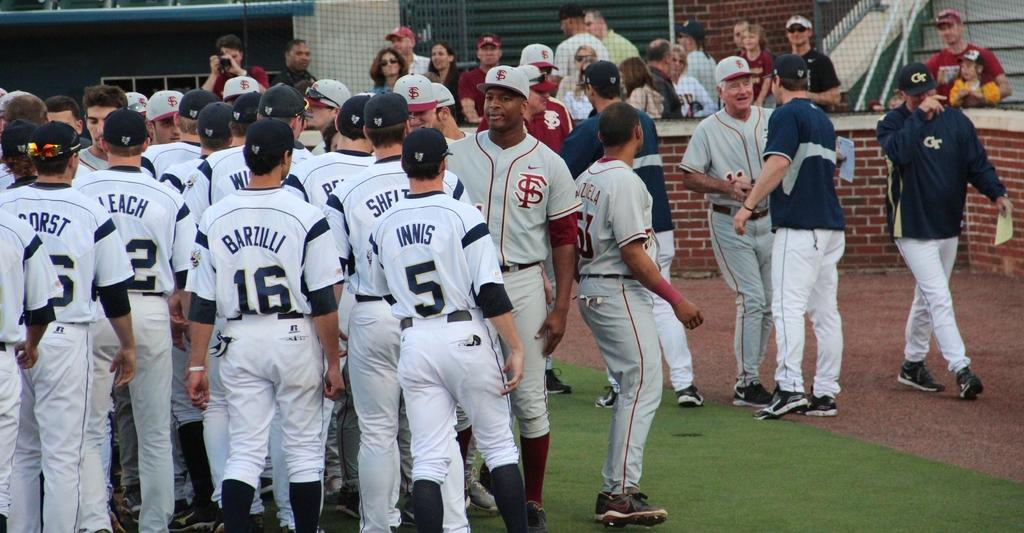Provide a one-sentence caption for the provided image. Barzilli is amongst his fellow teammates at the ball field. 